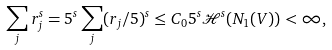<formula> <loc_0><loc_0><loc_500><loc_500>\sum _ { j } r _ { j } ^ { s } = 5 ^ { s } \sum _ { j } ( r _ { j } / 5 ) ^ { s } \leq C _ { 0 } 5 ^ { s } \mathcal { H } ^ { s } ( N _ { 1 } ( V ) ) < \infty ,</formula> 